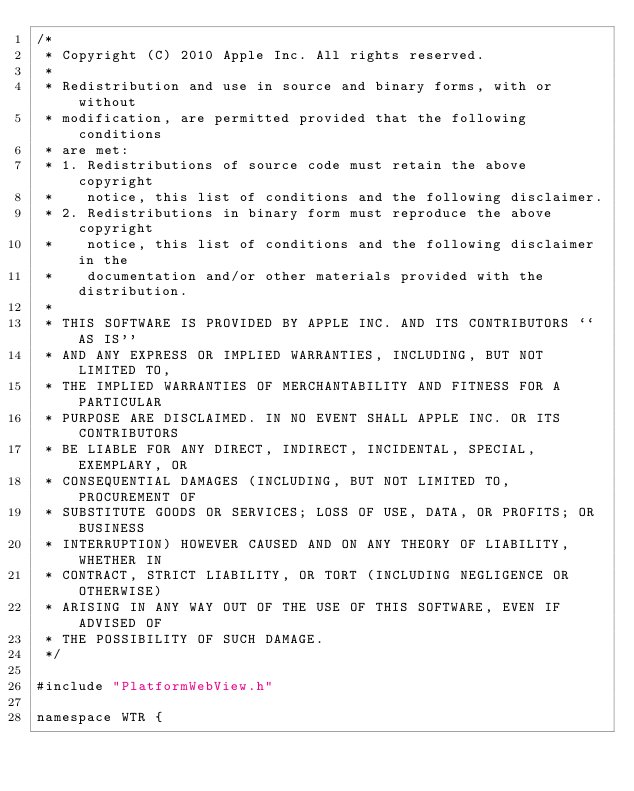<code> <loc_0><loc_0><loc_500><loc_500><_ObjectiveC_>/*
 * Copyright (C) 2010 Apple Inc. All rights reserved.
 *
 * Redistribution and use in source and binary forms, with or without
 * modification, are permitted provided that the following conditions
 * are met:
 * 1. Redistributions of source code must retain the above copyright
 *    notice, this list of conditions and the following disclaimer.
 * 2. Redistributions in binary form must reproduce the above copyright
 *    notice, this list of conditions and the following disclaimer in the
 *    documentation and/or other materials provided with the distribution.
 *
 * THIS SOFTWARE IS PROVIDED BY APPLE INC. AND ITS CONTRIBUTORS ``AS IS''
 * AND ANY EXPRESS OR IMPLIED WARRANTIES, INCLUDING, BUT NOT LIMITED TO,
 * THE IMPLIED WARRANTIES OF MERCHANTABILITY AND FITNESS FOR A PARTICULAR
 * PURPOSE ARE DISCLAIMED. IN NO EVENT SHALL APPLE INC. OR ITS CONTRIBUTORS
 * BE LIABLE FOR ANY DIRECT, INDIRECT, INCIDENTAL, SPECIAL, EXEMPLARY, OR
 * CONSEQUENTIAL DAMAGES (INCLUDING, BUT NOT LIMITED TO, PROCUREMENT OF
 * SUBSTITUTE GOODS OR SERVICES; LOSS OF USE, DATA, OR PROFITS; OR BUSINESS
 * INTERRUPTION) HOWEVER CAUSED AND ON ANY THEORY OF LIABILITY, WHETHER IN
 * CONTRACT, STRICT LIABILITY, OR TORT (INCLUDING NEGLIGENCE OR OTHERWISE)
 * ARISING IN ANY WAY OUT OF THE USE OF THIS SOFTWARE, EVEN IF ADVISED OF
 * THE POSSIBILITY OF SUCH DAMAGE.
 */

#include "PlatformWebView.h"

namespace WTR {
</code> 